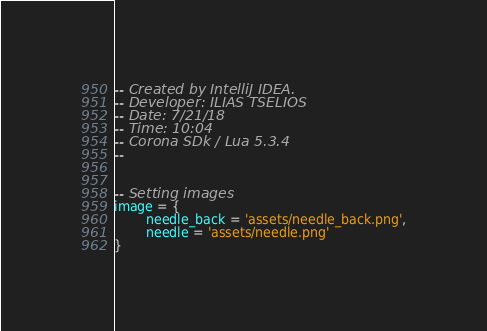<code> <loc_0><loc_0><loc_500><loc_500><_Lua_>-- Created by IntelliJ IDEA.
-- Developer: ILIAS TSELIOS
-- Date: 7/21/18
-- Time: 10:04
-- Corona SDk / Lua 5.3.4
--


-- Setting images
image = {
        needle_back = 'assets/needle_back.png',
        needle = 'assets/needle.png'
}
</code> 